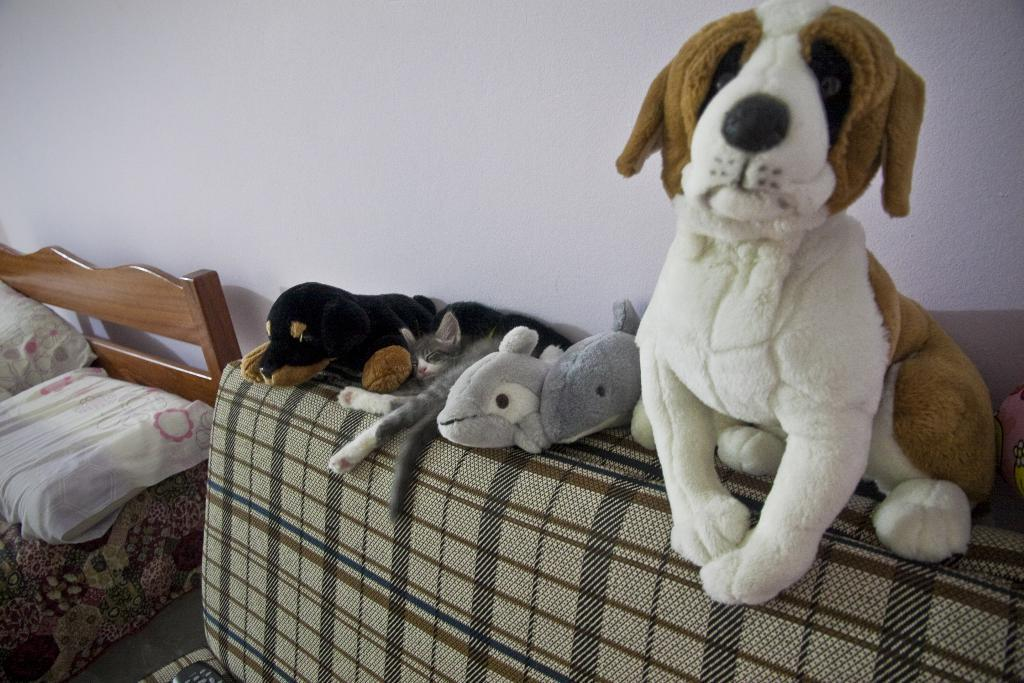What type of furniture is present in the image? There is a sofa in the image. What is placed on the sofa? Toys are placed on the sofa. How much money is hidden under the sofa cushions in the image? There is no mention of money or any hidden objects under the sofa cushions in the image. 